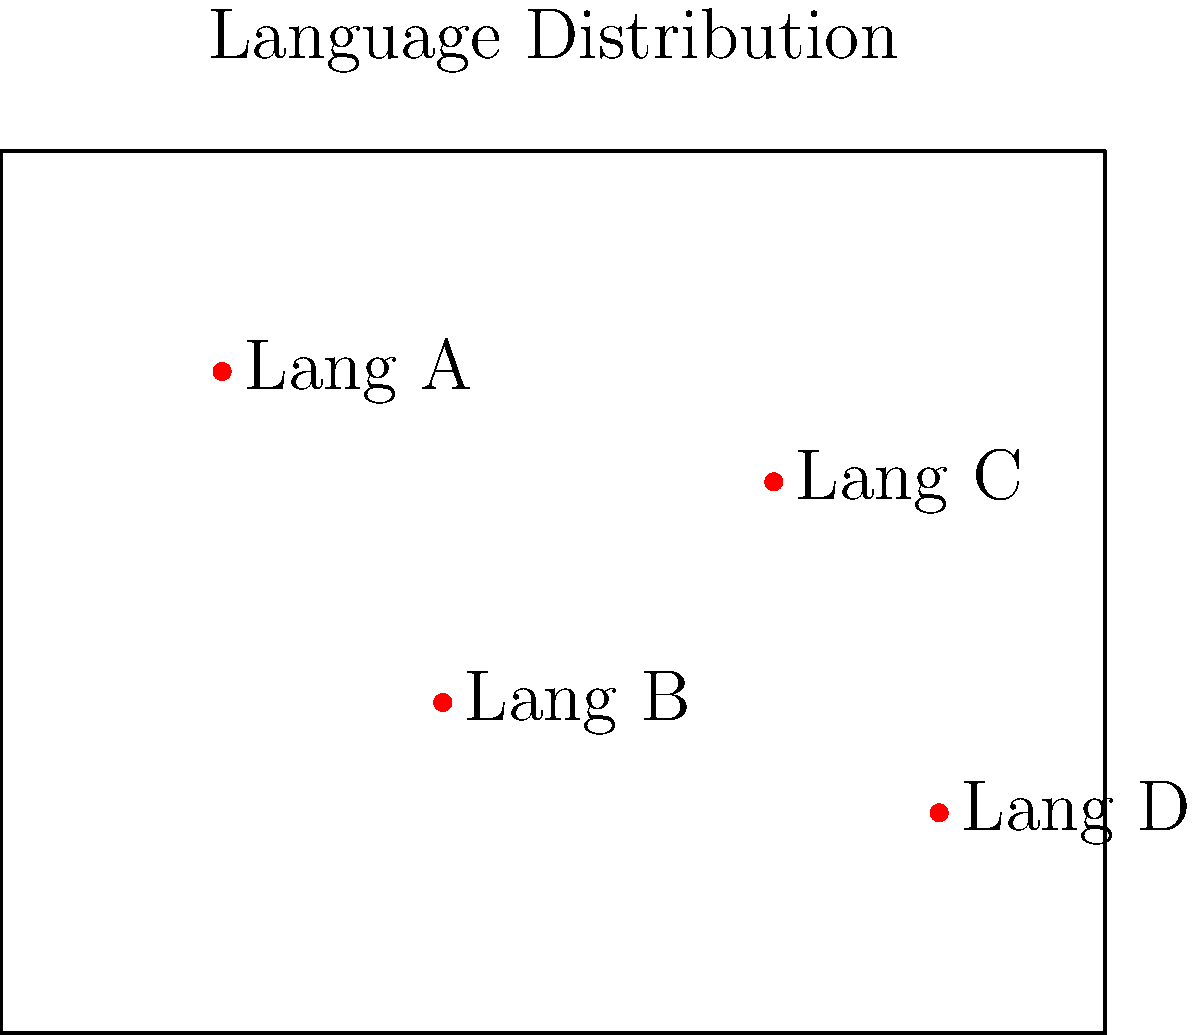You are designing an interactive map to visualize the geographical distribution of tribal language speakers. The map above shows the distribution of four languages (A, B, C, and D) in a region. Which data structure would be most efficient for storing the geographical coordinates and associated language information to allow for quick retrieval and updates in your interactive map application? To determine the most efficient data structure for this interactive map application, let's consider the requirements and characteristics of the data:

1. We need to store geographical coordinates (latitude and longitude) for each language point.
2. We need to associate each point with a language name.
3. The application requires quick retrieval of information for interactivity.
4. We may need to update the information or add new language points.

Given these requirements, let's evaluate some potential data structures:

1. Array: Simple but not ideal for frequent updates or searches.
2. Linked List: Good for insertions but poor for random access and searches.
3. Hash Table: Excellent for quick retrieval but doesn't preserve geographical relationships.
4. Tree-based structures (e.g., B-tree, R-tree): Good for range queries and preserving spatial relationships.

Considering the spatial nature of the data and the need for quick retrieval and updates, the most efficient data structure would be a spatial index, specifically an R-tree.

An R-tree is a tree-based data structure designed for spatial data. It groups nearby objects and represents them with their minimum bounding rectangle in the next higher level of the tree. This structure allows for efficient range searches and nearest neighbor queries, which are essential for an interactive map.

The R-tree structure would allow:
1. Quick retrieval of language information for a given geographical area.
2. Efficient updates when adding or modifying language data points.
3. Easy implementation of features like zooming and panning on the interactive map.
4. Scalability to handle a large number of language points across a wide geographical area.

Therefore, an R-tree would be the most efficient data structure for this application, balancing the needs for quick retrieval, updates, and spatial relationship preservation.
Answer: R-tree 